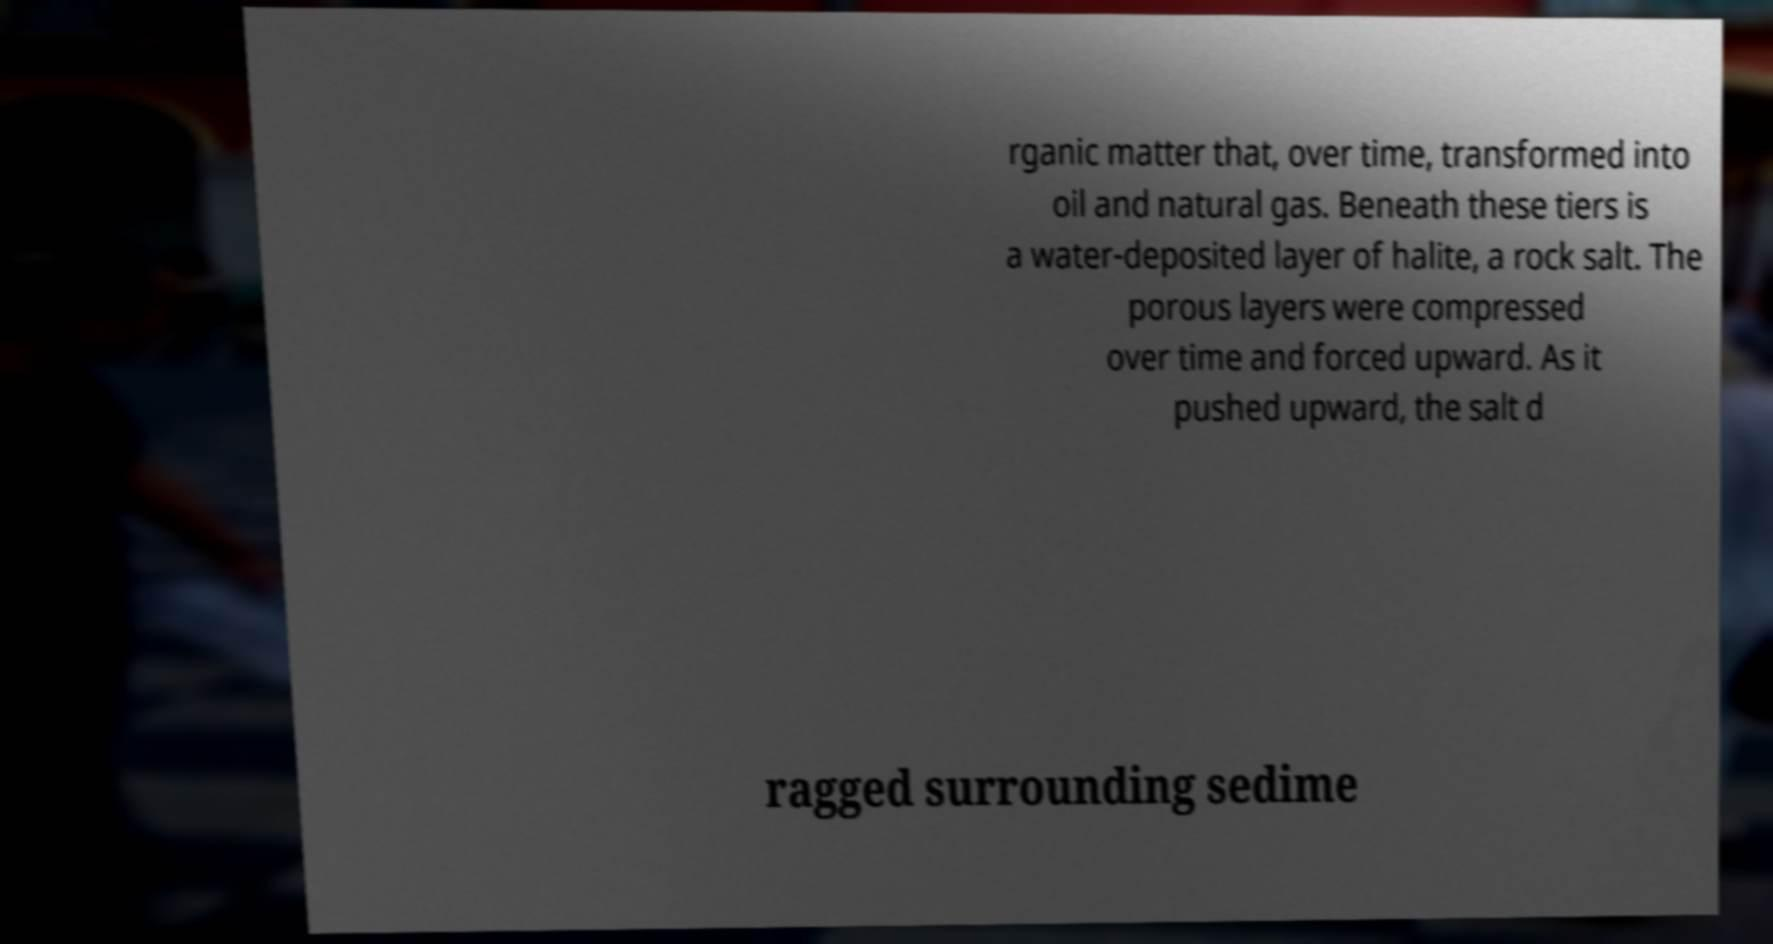There's text embedded in this image that I need extracted. Can you transcribe it verbatim? rganic matter that, over time, transformed into oil and natural gas. Beneath these tiers is a water-deposited layer of halite, a rock salt. The porous layers were compressed over time and forced upward. As it pushed upward, the salt d ragged surrounding sedime 